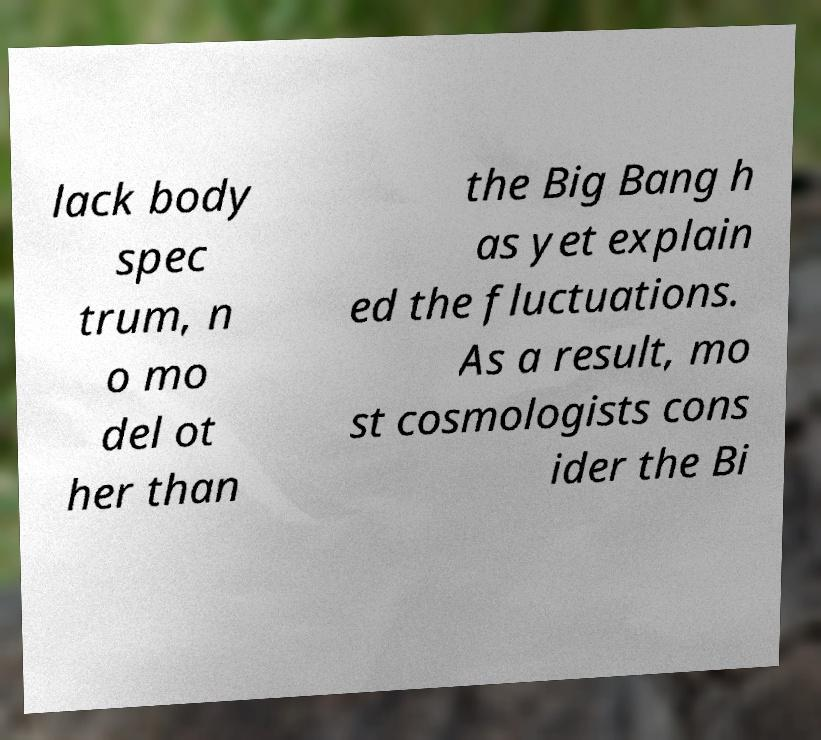Can you read and provide the text displayed in the image?This photo seems to have some interesting text. Can you extract and type it out for me? lack body spec trum, n o mo del ot her than the Big Bang h as yet explain ed the fluctuations. As a result, mo st cosmologists cons ider the Bi 